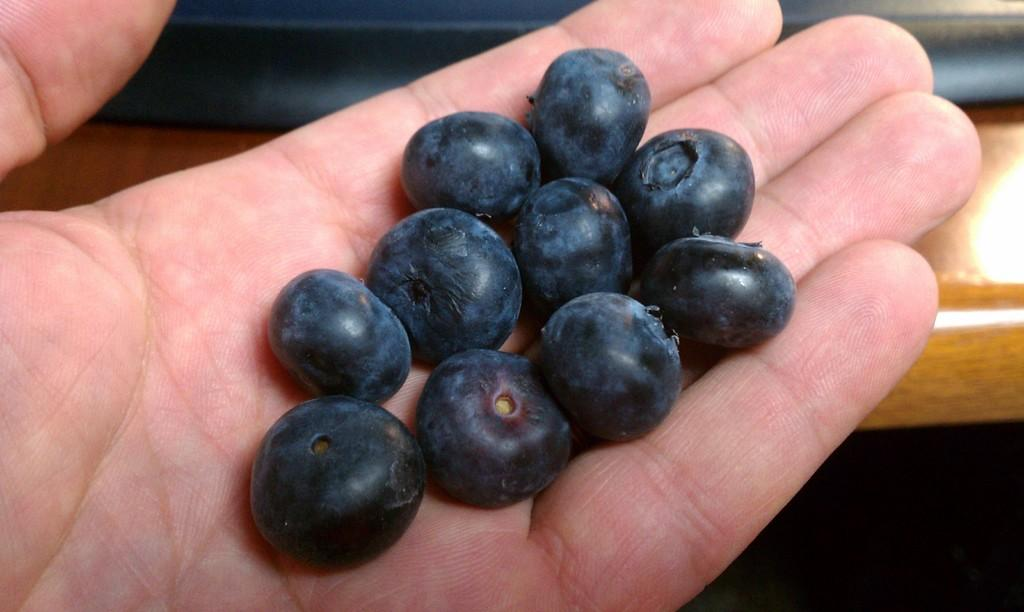What can be seen in the image that belongs to a person? There is a person's hand in the image. What is the person holding in the image? The person is holding blueberries. What type of object is in the center of the image? There is a wooden object in the center of the image. What type of soup can be seen in the wooden object in the image? There is no soup present in the image; it features a person's hand holding blueberries and a wooden object in the center. How many dogs are visible in the image? There are no dogs present in the image. 